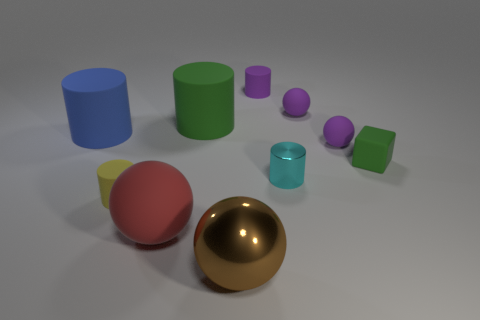Can you describe the various objects and their colors in the image? Certainly! In this image, we see a collection of geometric shapes. There's a large red sphere and a smaller purple sphere. We can also see a large blue cylinder, a medium green cylinder, and a small teal cylinder. Then there's a large gold sphere, which is quite reflective. Lastly, there are two cuboids – one purple and one green. 